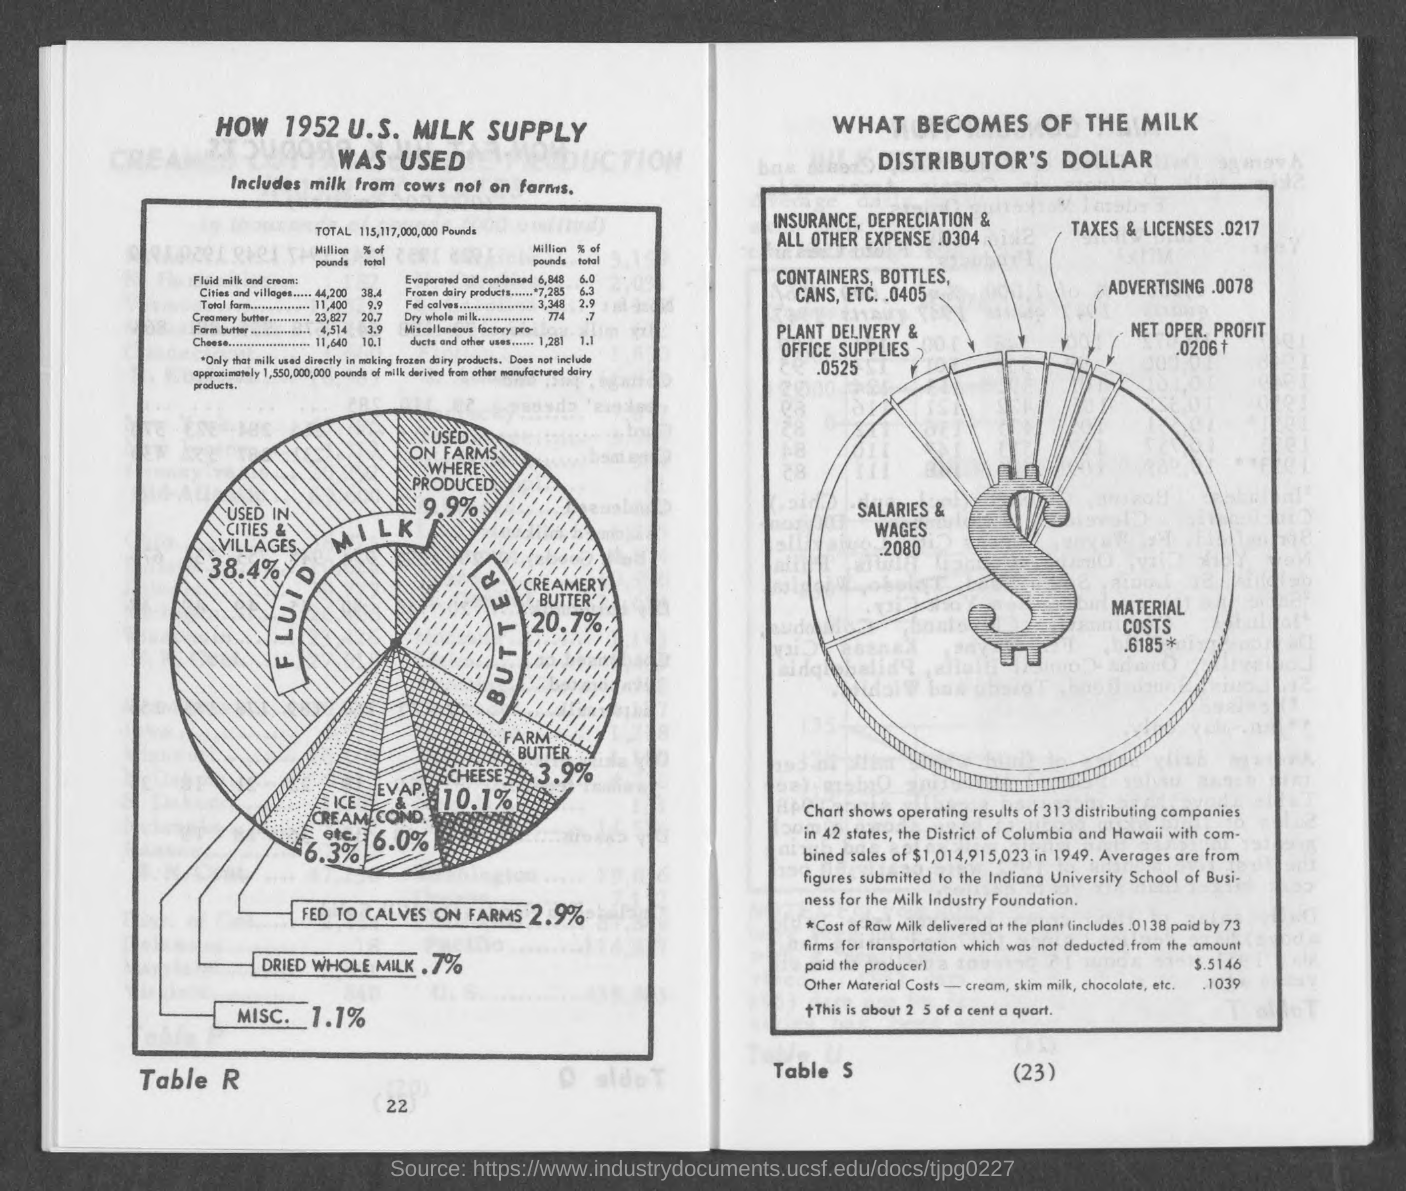Outline some significant characteristics in this image. What is the number in the table labeled R? 